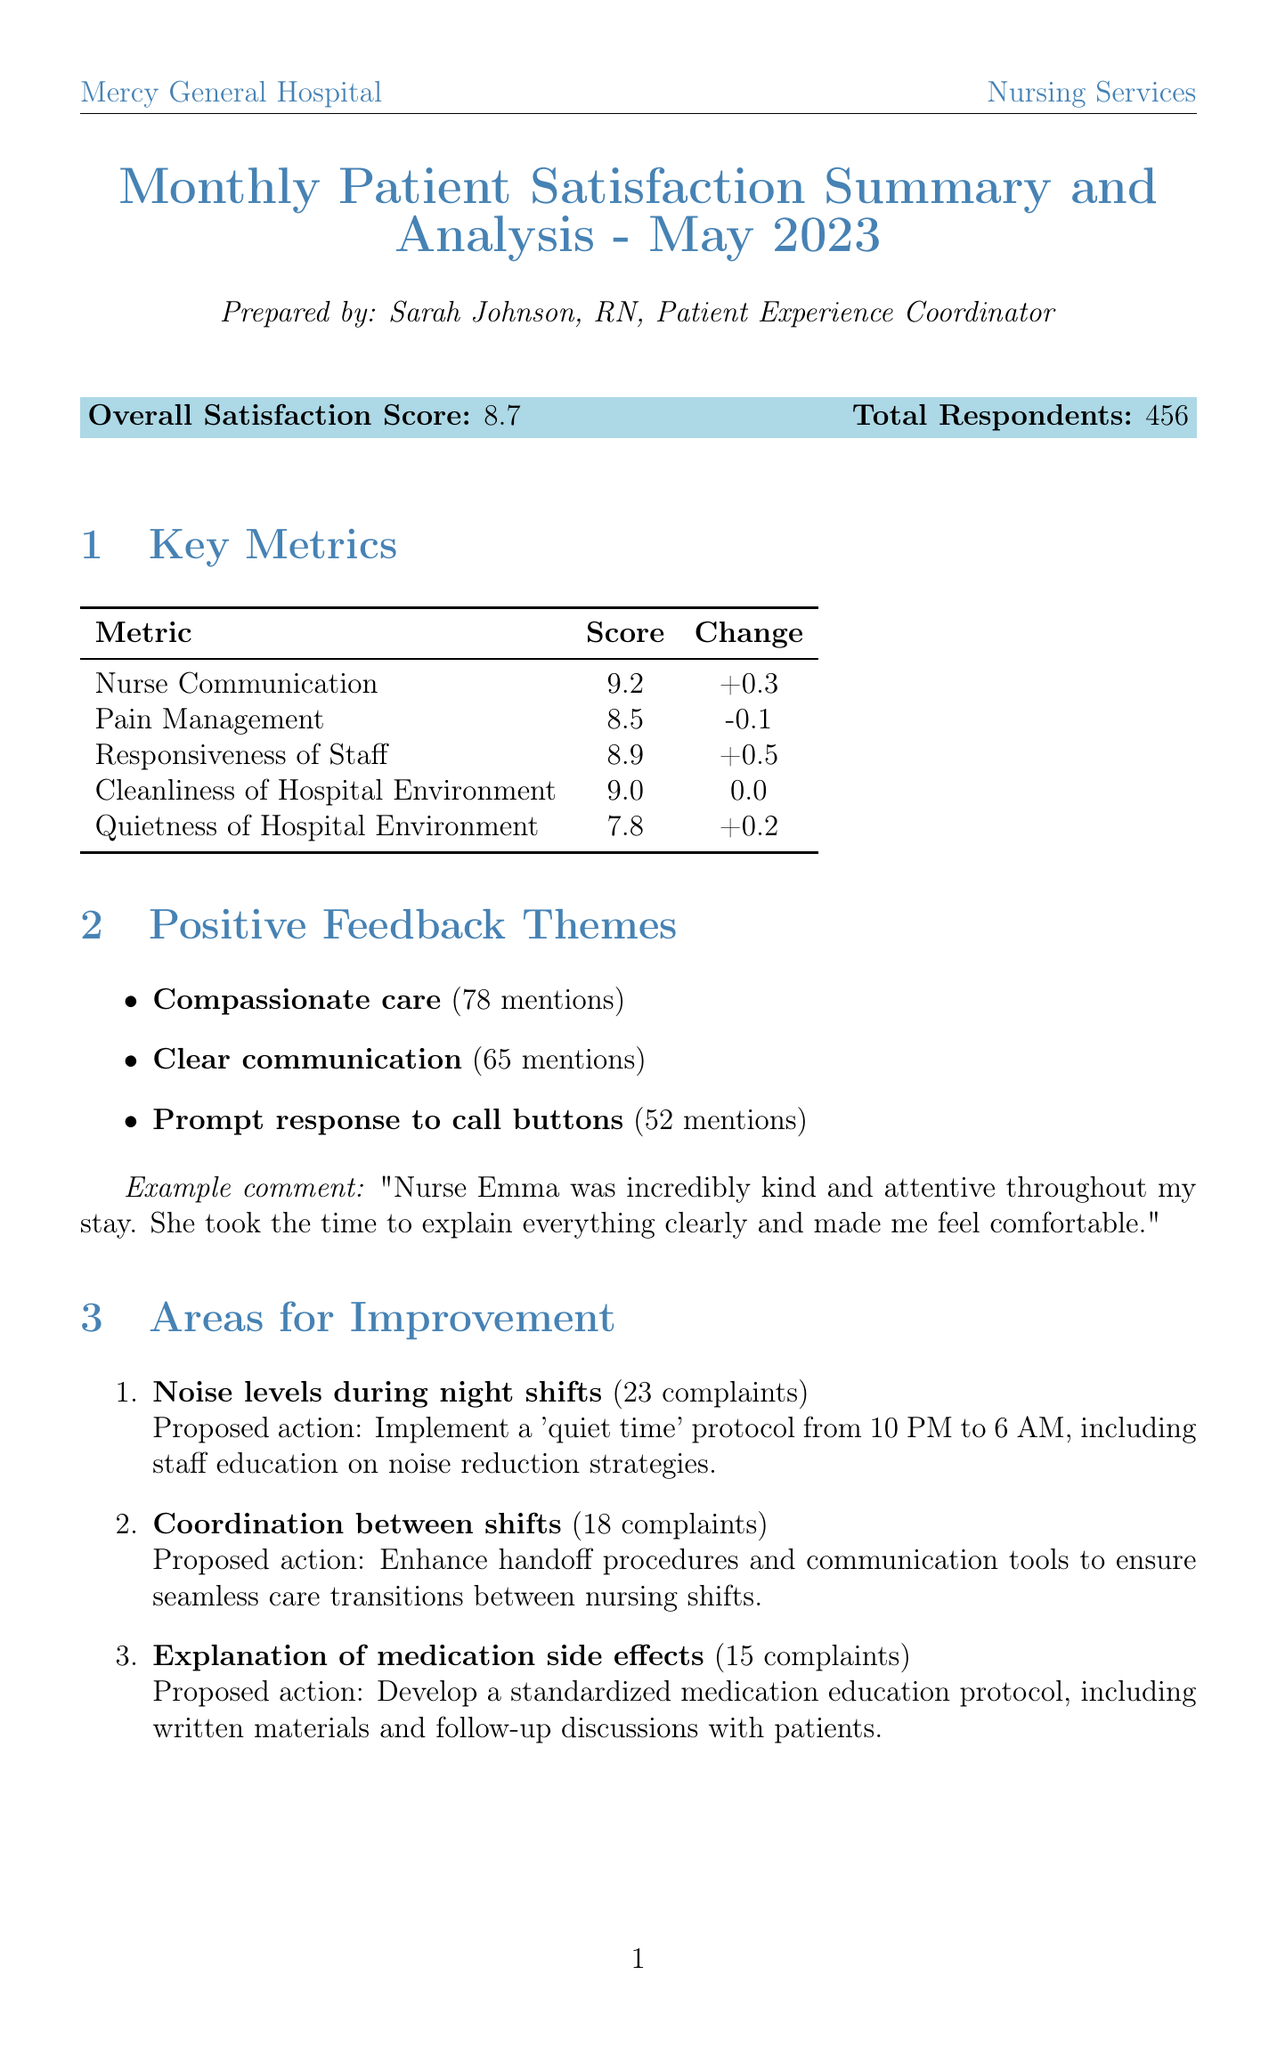What is the overall satisfaction score? The overall satisfaction score is listed prominently in the report summary.
Answer: 8.7 Who prepared the report? The document states the name of the person who prepared it, indicating their role within the hospital.
Answer: Sarah Johnson, RN, Patient Experience Coordinator What was the score for Nurse Communication? The score for this specific metric is provided in the key metrics section of the report.
Answer: 9.2 How many respondents provided feedback in total? The total number of respondents is clearly stated in the summary section.
Answer: 456 What is an area identified for improvement? The report lists several areas that need attention, focusing on patient feedback and satisfaction.
Answer: Noise levels during night shifts How many patient commendations did Emma Thompson receive? The staff recognition section highlights achievements, including the number of commendations received by staff members.
Answer: 12 What initiative is planned to improve patient understanding? Upcoming initiatives section outlines projects designed to enhance patient care and education.
Answer: Patient Education Video Series Which metric had the highest score? The key metrics detail various satisfaction scores, allowing for a comparison across different measures.
Answer: Nurse Communication What was the proposed action for medication side effects? The document outlines actions proposed to address specific feedback from patients.
Answer: Develop a standardized medication education protocol 